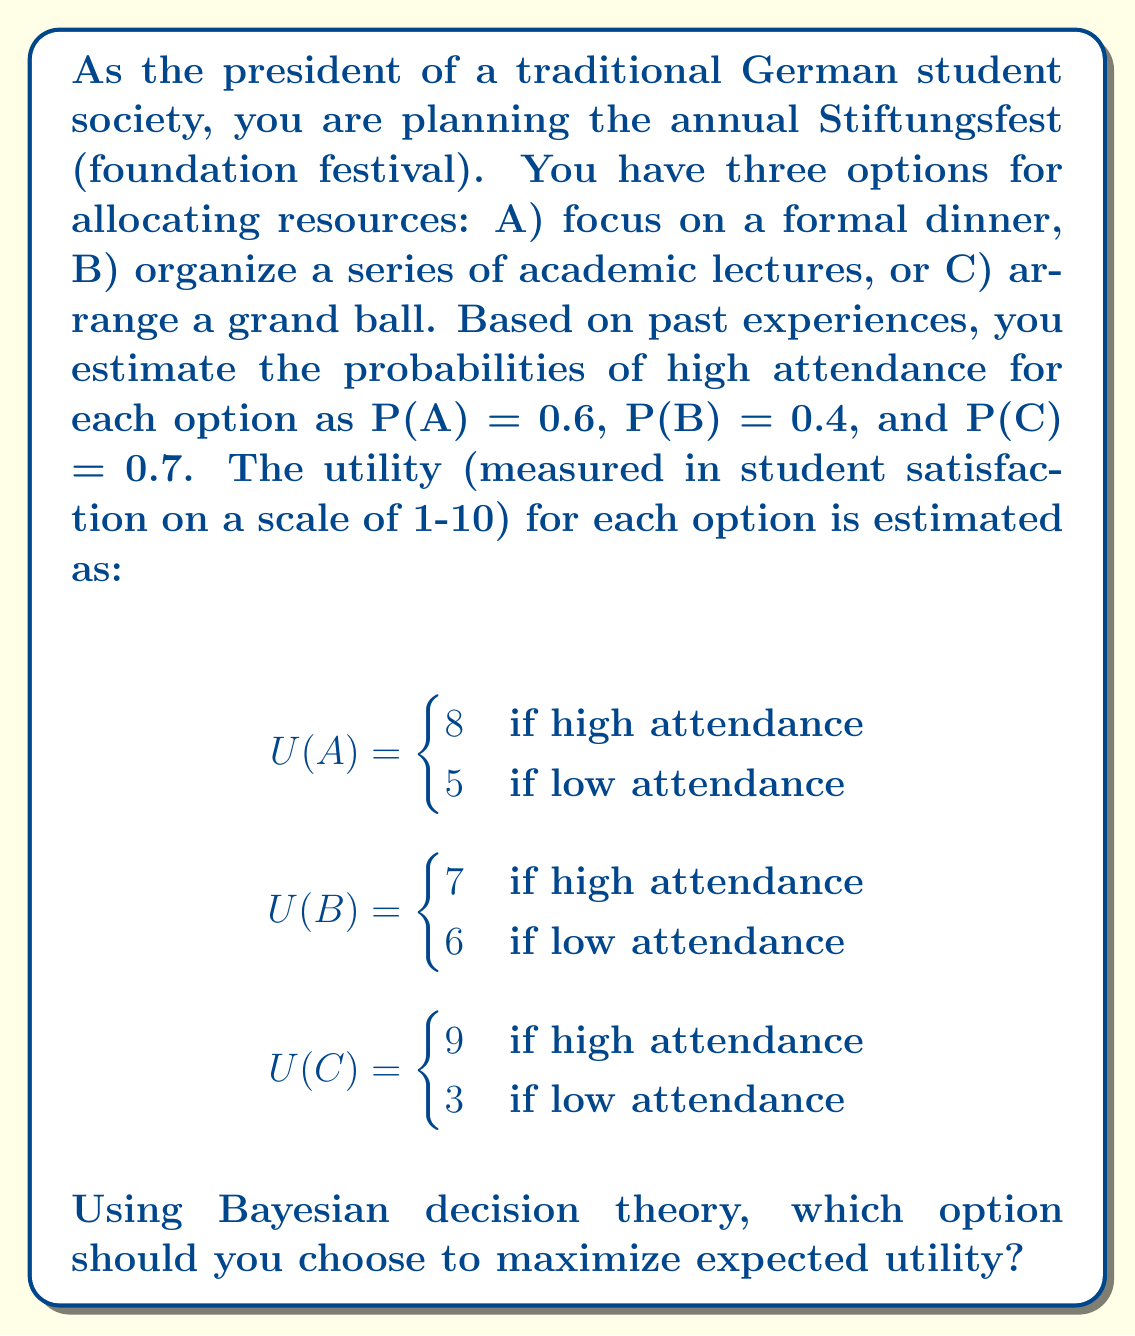Teach me how to tackle this problem. To solve this problem using Bayesian decision theory, we need to calculate the expected utility for each option and choose the one with the highest value.

For each option, the expected utility is calculated as:

$E[U(X)] = P(X) \cdot U(X|\text{high attendance}) + (1-P(X)) \cdot U(X|\text{low attendance})$

Where $X$ is the option (A, B, or C).

Let's calculate for each option:

1. Option A (formal dinner):
   $E[U(A)] = 0.6 \cdot 8 + 0.4 \cdot 5 = 4.8 + 2 = 6.8$

2. Option B (academic lectures):
   $E[U(B)] = 0.4 \cdot 7 + 0.6 \cdot 6 = 2.8 + 3.6 = 6.4$

3. Option C (grand ball):
   $E[U(C)] = 0.7 \cdot 9 + 0.3 \cdot 3 = 6.3 + 0.9 = 7.2$

Comparing the expected utilities:
$E[U(C)] > E[U(A)] > E[U(B)]$

Therefore, option C (grand ball) has the highest expected utility.
Answer: Option C (grand ball) should be chosen to maximize expected utility, with an expected utility of 7.2. 